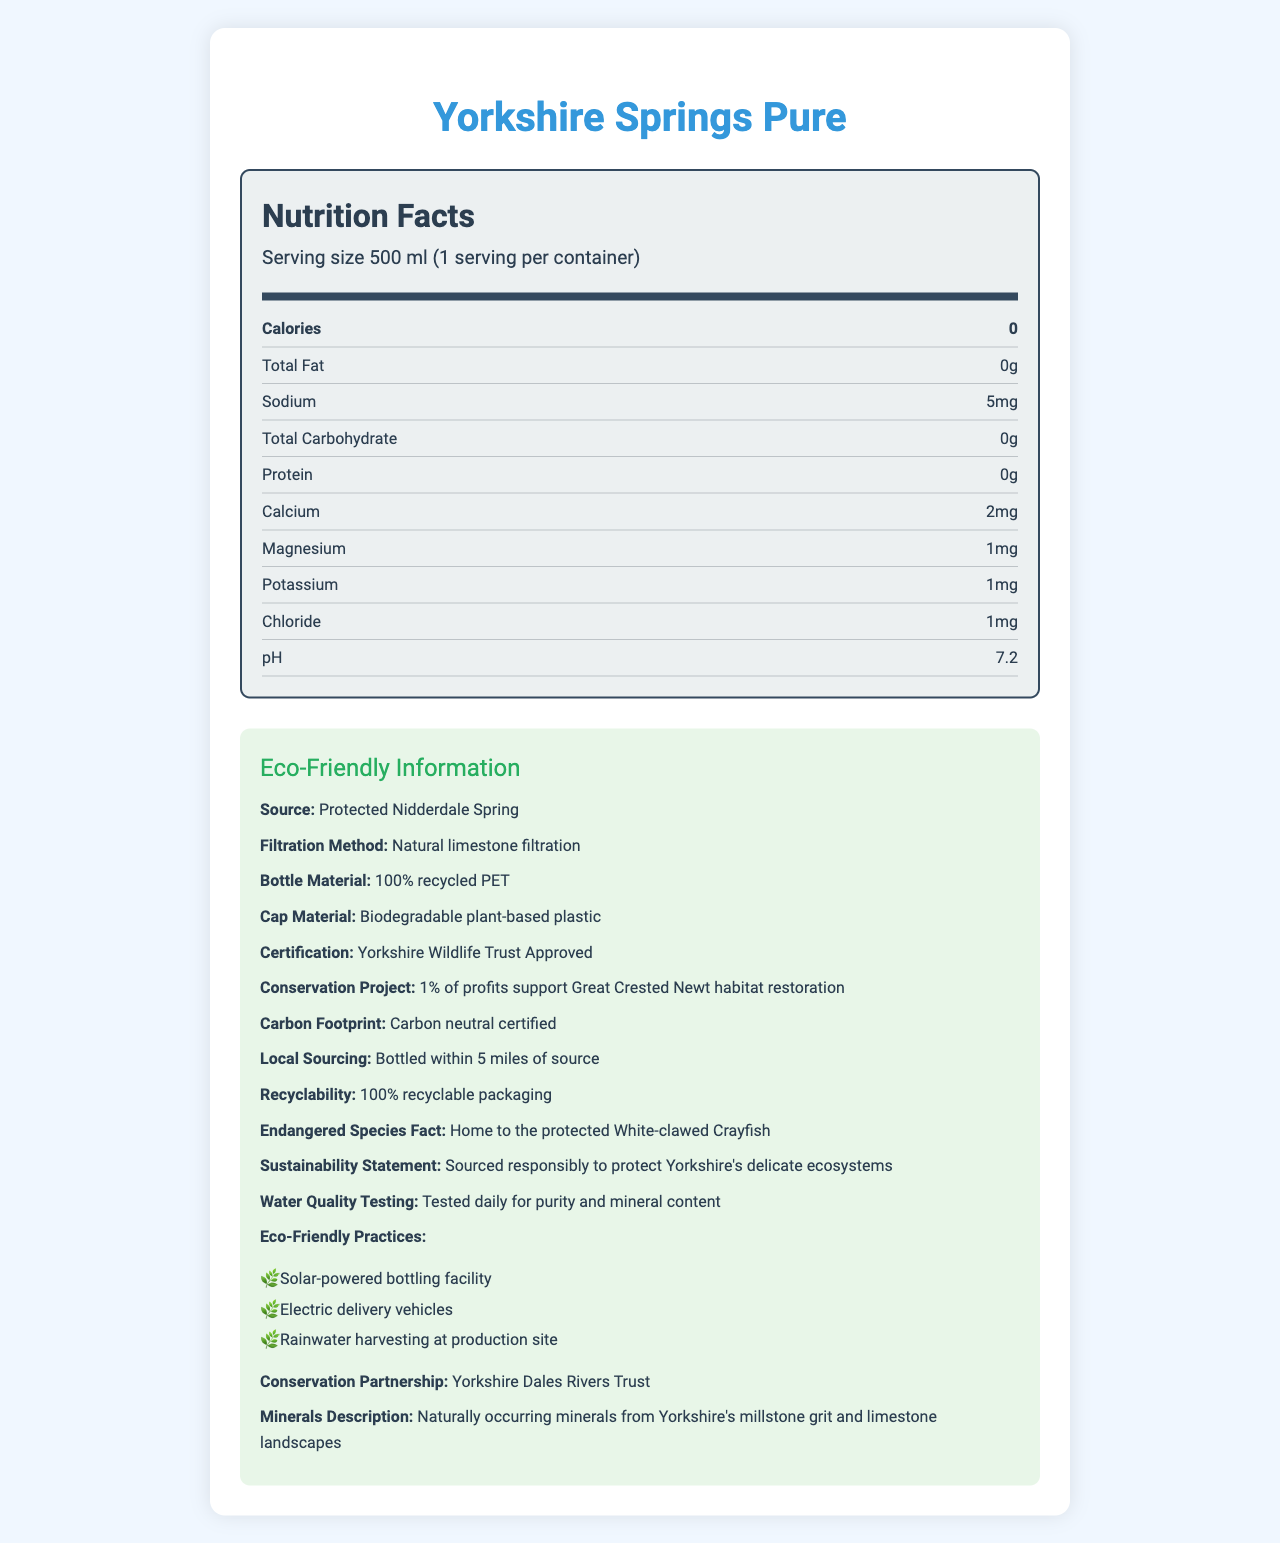what is the serving size? The document states that the serving size is "500 ml".
Answer: 500 ml how many servings are there per container? The document mentions "1 serving per container".
Answer: 1 how many calories does the product have? The document clearly indicates that the product has "0 calories".
Answer: 0 what is the amount of sodium in the product? According to the document, the sodium content is "5mg".
Answer: 5mg how is the water filtered? The document specifies that the filtration method is "Natural limestone filtration".
Answer: Natural limestone filtration which of the following materials is used for the bottle cap? A. PET B. Plant-based plastic C. Glass The document mentions that the cap is made from "Biodegradable plant-based plastic".
Answer: B. Plant-based plastic what certification does the product have? A. FDA Approved B. Yorkshire Wildlife Trust Approved C. Organic Certified The document states that the product is "Yorkshire Wildlife Trust Approved".
Answer: B. Yorkshire Wildlife Trust Approved is the packaging recyclable? The document states that the packaging is "100% recyclable".
Answer: Yes describe the eco-friendly practices mentioned in the document. The document lists the eco-friendly practices, which include a solar-powered bottling facility, electric delivery vehicles, and rainwater harvesting at the production site.
Answer: Solar-powered bottling facility, Electric delivery vehicles, Rainwater harvesting at production site what is the purpose of the conservation project supported by this product? The document states that "1% of profits support Great Crested Newt habitat restoration".
Answer: To support Great Crested Newt habitat restoration what is the mineral content of calcium in this product? The document indicates that the calcium content is "2mg".
Answer: 2mg what type of plastic is used for the bottle? The bottle is made of "100% recycled PET" as mentioned in the document.
Answer: 100% recycled PET explain the carbon footprint certification of the product. The document states that the product is "Carbon neutral certified", meaning the production process ensures that any carbon emissions are offset.
Answer: Carbon neutral certified what is the pH level of the water? The document notes that the water has a pH of "7.2".
Answer: 7.2 what animal is highlighted as an endangered species in the document? The document states that the area is home to the "protected White-clawed Crayfish".
Answer: White-clawed Crayfish can we determine the exact date when the water was tested for purity? The document mentions that the water is "Tested daily for purity and mineral content," but it does not provide specific dates.
Answer: Not enough information 